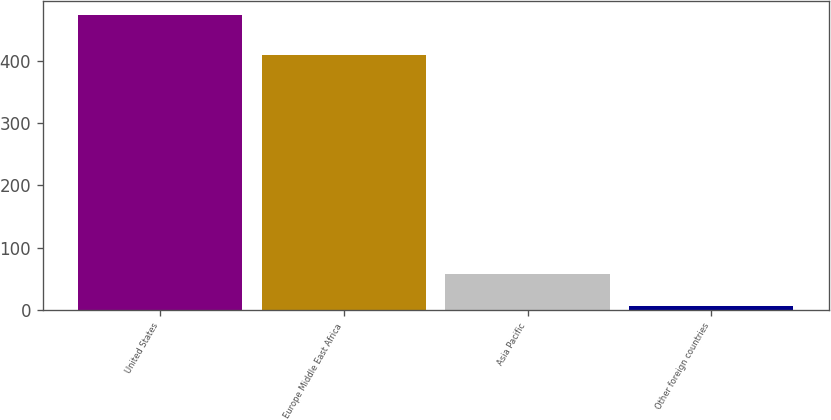Convert chart to OTSL. <chart><loc_0><loc_0><loc_500><loc_500><bar_chart><fcel>United States<fcel>Europe Middle East Africa<fcel>Asia Pacific<fcel>Other foreign countries<nl><fcel>473<fcel>410<fcel>58<fcel>7<nl></chart> 